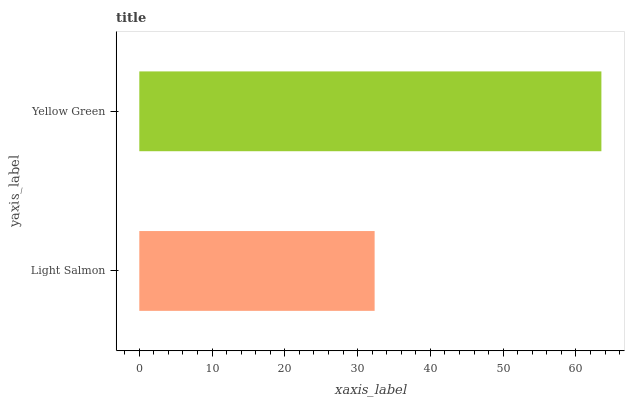Is Light Salmon the minimum?
Answer yes or no. Yes. Is Yellow Green the maximum?
Answer yes or no. Yes. Is Yellow Green the minimum?
Answer yes or no. No. Is Yellow Green greater than Light Salmon?
Answer yes or no. Yes. Is Light Salmon less than Yellow Green?
Answer yes or no. Yes. Is Light Salmon greater than Yellow Green?
Answer yes or no. No. Is Yellow Green less than Light Salmon?
Answer yes or no. No. Is Yellow Green the high median?
Answer yes or no. Yes. Is Light Salmon the low median?
Answer yes or no. Yes. Is Light Salmon the high median?
Answer yes or no. No. Is Yellow Green the low median?
Answer yes or no. No. 